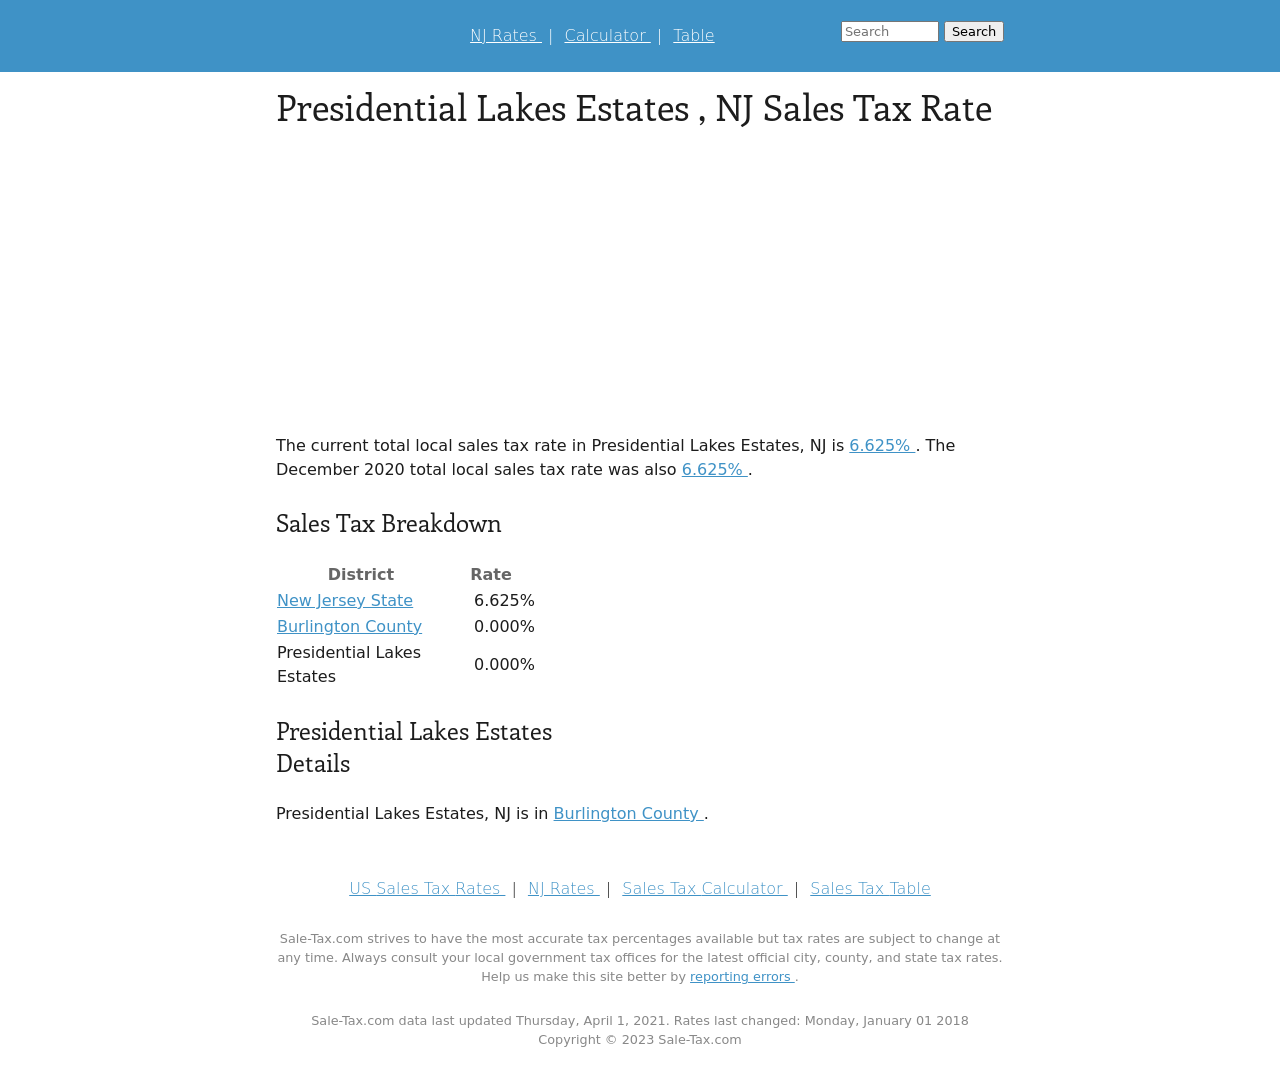Can you explain more about the significance of having a visual breakdown of sales tax on a website? A visual breakdown of sales tax, like the one displayed in the image, significantly enhances user comprehension. It provides a clear, accessible presentation of complex data which can facilitate better decision-making for businesses and consumers. Visualizing the tax rates directly compares different regions, prompting more informed financial planning and compliance with local tax regulations. 